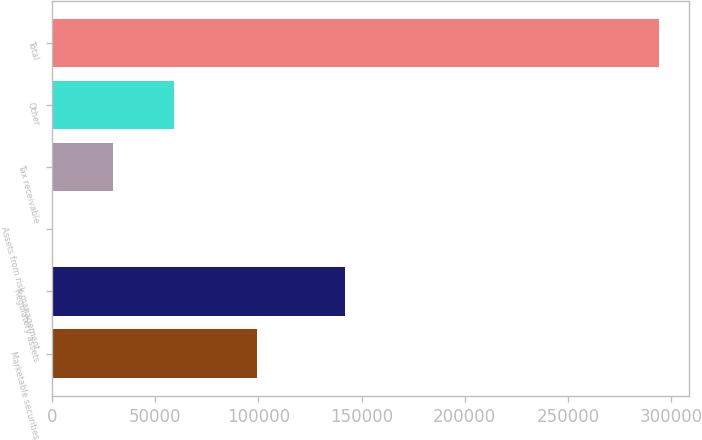Convert chart. <chart><loc_0><loc_0><loc_500><loc_500><bar_chart><fcel>Marketable securities<fcel>Regulatory assets<fcel>Assets from risk management<fcel>Tax receivable<fcel>Other<fcel>Total<nl><fcel>99385<fcel>141778<fcel>250<fcel>29626.8<fcel>59003.6<fcel>294018<nl></chart> 